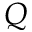<formula> <loc_0><loc_0><loc_500><loc_500>Q</formula> 